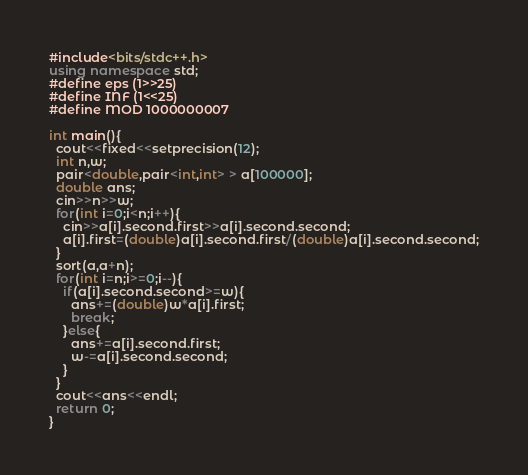Convert code to text. <code><loc_0><loc_0><loc_500><loc_500><_C++_>#include<bits/stdc++.h>
using namespace std;
#define eps (1>>25)
#define INF (1<<25)
#define MOD 1000000007

int main(){
  cout<<fixed<<setprecision(12);
  int n,w;
  pair<double,pair<int,int> > a[100000];
  double ans;
  cin>>n>>w;
  for(int i=0;i<n;i++){
    cin>>a[i].second.first>>a[i].second.second;
    a[i].first=(double)a[i].second.first/(double)a[i].second.second;
  }
  sort(a,a+n);
  for(int i=n;i>=0;i--){
    if(a[i].second.second>=w){
      ans+=(double)w*a[i].first;
      break;
    }else{
      ans+=a[i].second.first;
      w-=a[i].second.second;
    }
  }
  cout<<ans<<endl;
  return 0;
}

</code> 